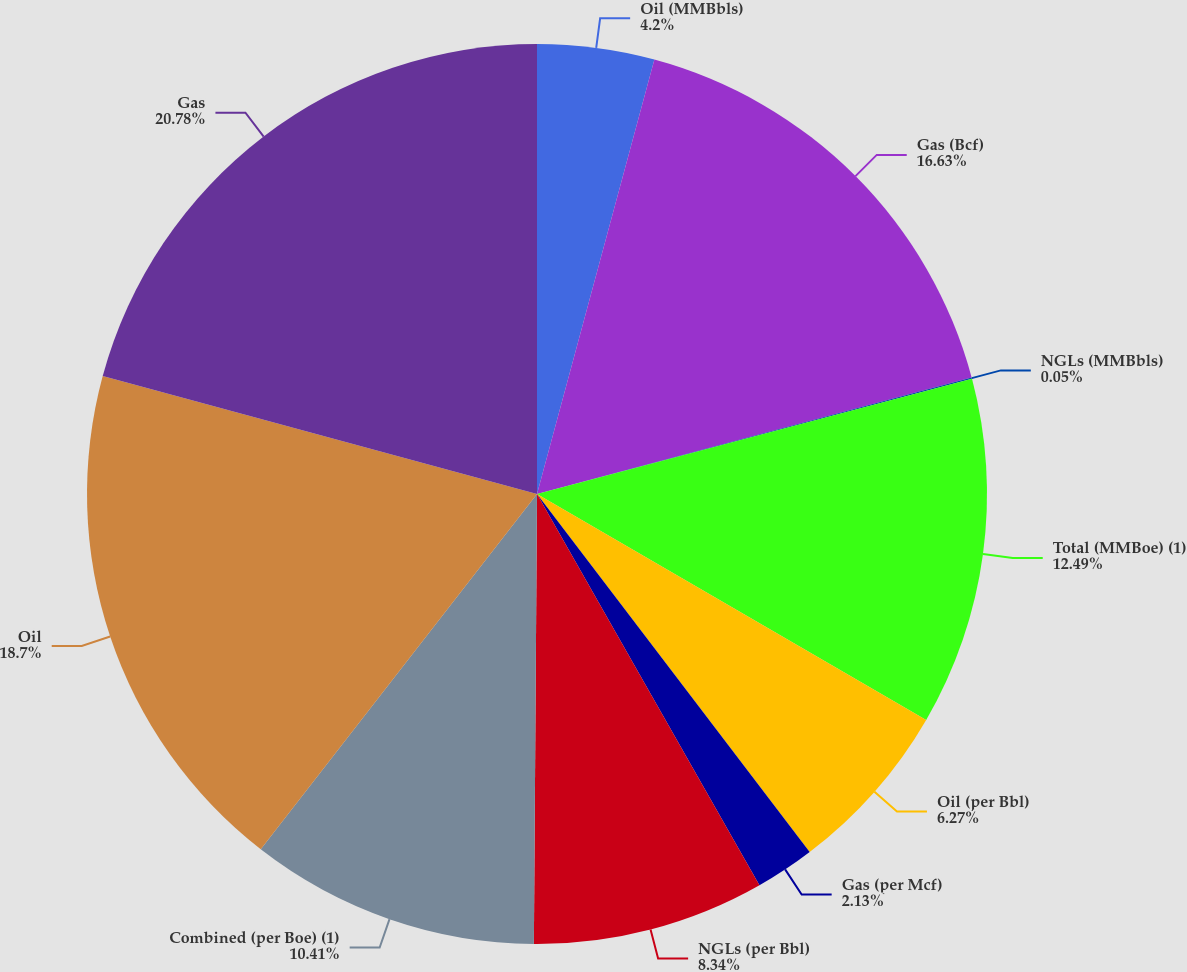Convert chart. <chart><loc_0><loc_0><loc_500><loc_500><pie_chart><fcel>Oil (MMBbls)<fcel>Gas (Bcf)<fcel>NGLs (MMBbls)<fcel>Total (MMBoe) (1)<fcel>Oil (per Bbl)<fcel>Gas (per Mcf)<fcel>NGLs (per Bbl)<fcel>Combined (per Boe) (1)<fcel>Oil<fcel>Gas<nl><fcel>4.2%<fcel>16.63%<fcel>0.05%<fcel>12.49%<fcel>6.27%<fcel>2.13%<fcel>8.34%<fcel>10.41%<fcel>18.7%<fcel>20.78%<nl></chart> 